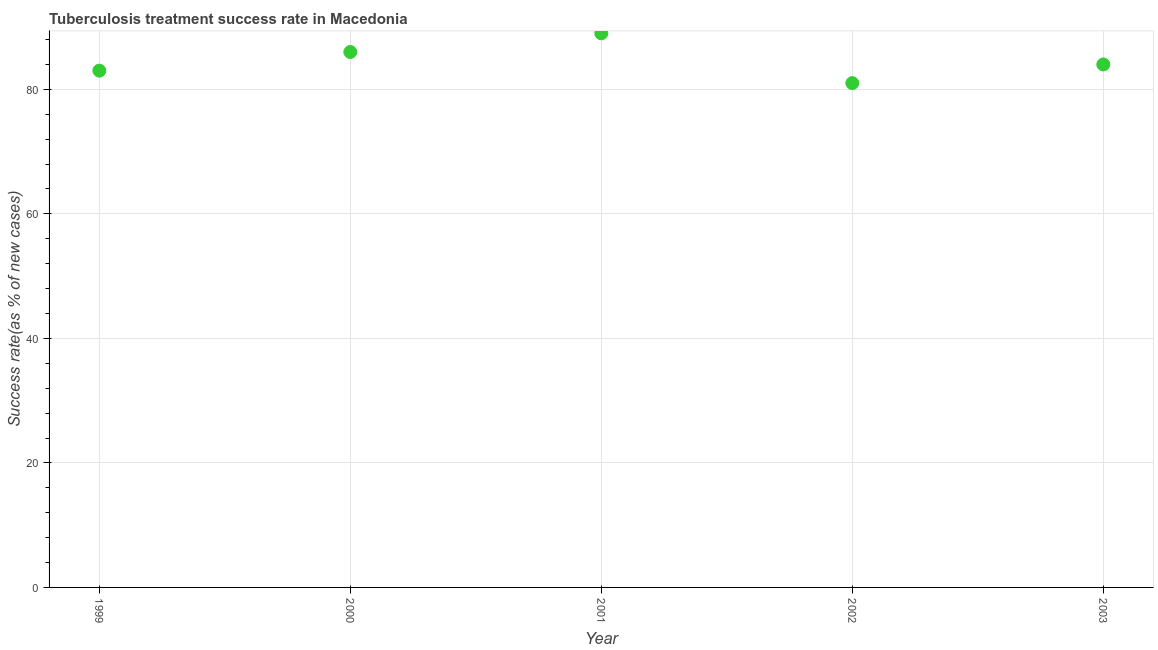What is the tuberculosis treatment success rate in 2000?
Give a very brief answer. 86. Across all years, what is the maximum tuberculosis treatment success rate?
Keep it short and to the point. 89. Across all years, what is the minimum tuberculosis treatment success rate?
Keep it short and to the point. 81. In which year was the tuberculosis treatment success rate maximum?
Keep it short and to the point. 2001. In which year was the tuberculosis treatment success rate minimum?
Provide a short and direct response. 2002. What is the sum of the tuberculosis treatment success rate?
Your response must be concise. 423. What is the difference between the tuberculosis treatment success rate in 2000 and 2002?
Provide a short and direct response. 5. What is the average tuberculosis treatment success rate per year?
Your answer should be compact. 84.6. Do a majority of the years between 1999 and 2002 (inclusive) have tuberculosis treatment success rate greater than 4 %?
Give a very brief answer. Yes. What is the ratio of the tuberculosis treatment success rate in 2000 to that in 2002?
Your answer should be very brief. 1.06. What is the difference between the highest and the lowest tuberculosis treatment success rate?
Your response must be concise. 8. Does the tuberculosis treatment success rate monotonically increase over the years?
Provide a short and direct response. No. How many years are there in the graph?
Your answer should be compact. 5. Are the values on the major ticks of Y-axis written in scientific E-notation?
Ensure brevity in your answer.  No. What is the title of the graph?
Keep it short and to the point. Tuberculosis treatment success rate in Macedonia. What is the label or title of the X-axis?
Offer a terse response. Year. What is the label or title of the Y-axis?
Keep it short and to the point. Success rate(as % of new cases). What is the Success rate(as % of new cases) in 2000?
Offer a very short reply. 86. What is the Success rate(as % of new cases) in 2001?
Make the answer very short. 89. What is the Success rate(as % of new cases) in 2002?
Your response must be concise. 81. What is the difference between the Success rate(as % of new cases) in 1999 and 2001?
Provide a short and direct response. -6. What is the difference between the Success rate(as % of new cases) in 1999 and 2002?
Keep it short and to the point. 2. What is the difference between the Success rate(as % of new cases) in 2000 and 2001?
Offer a terse response. -3. What is the difference between the Success rate(as % of new cases) in 2001 and 2003?
Your answer should be compact. 5. What is the ratio of the Success rate(as % of new cases) in 1999 to that in 2000?
Ensure brevity in your answer.  0.96. What is the ratio of the Success rate(as % of new cases) in 1999 to that in 2001?
Provide a succinct answer. 0.93. What is the ratio of the Success rate(as % of new cases) in 1999 to that in 2003?
Give a very brief answer. 0.99. What is the ratio of the Success rate(as % of new cases) in 2000 to that in 2002?
Offer a very short reply. 1.06. What is the ratio of the Success rate(as % of new cases) in 2001 to that in 2002?
Your response must be concise. 1.1. What is the ratio of the Success rate(as % of new cases) in 2001 to that in 2003?
Your response must be concise. 1.06. 